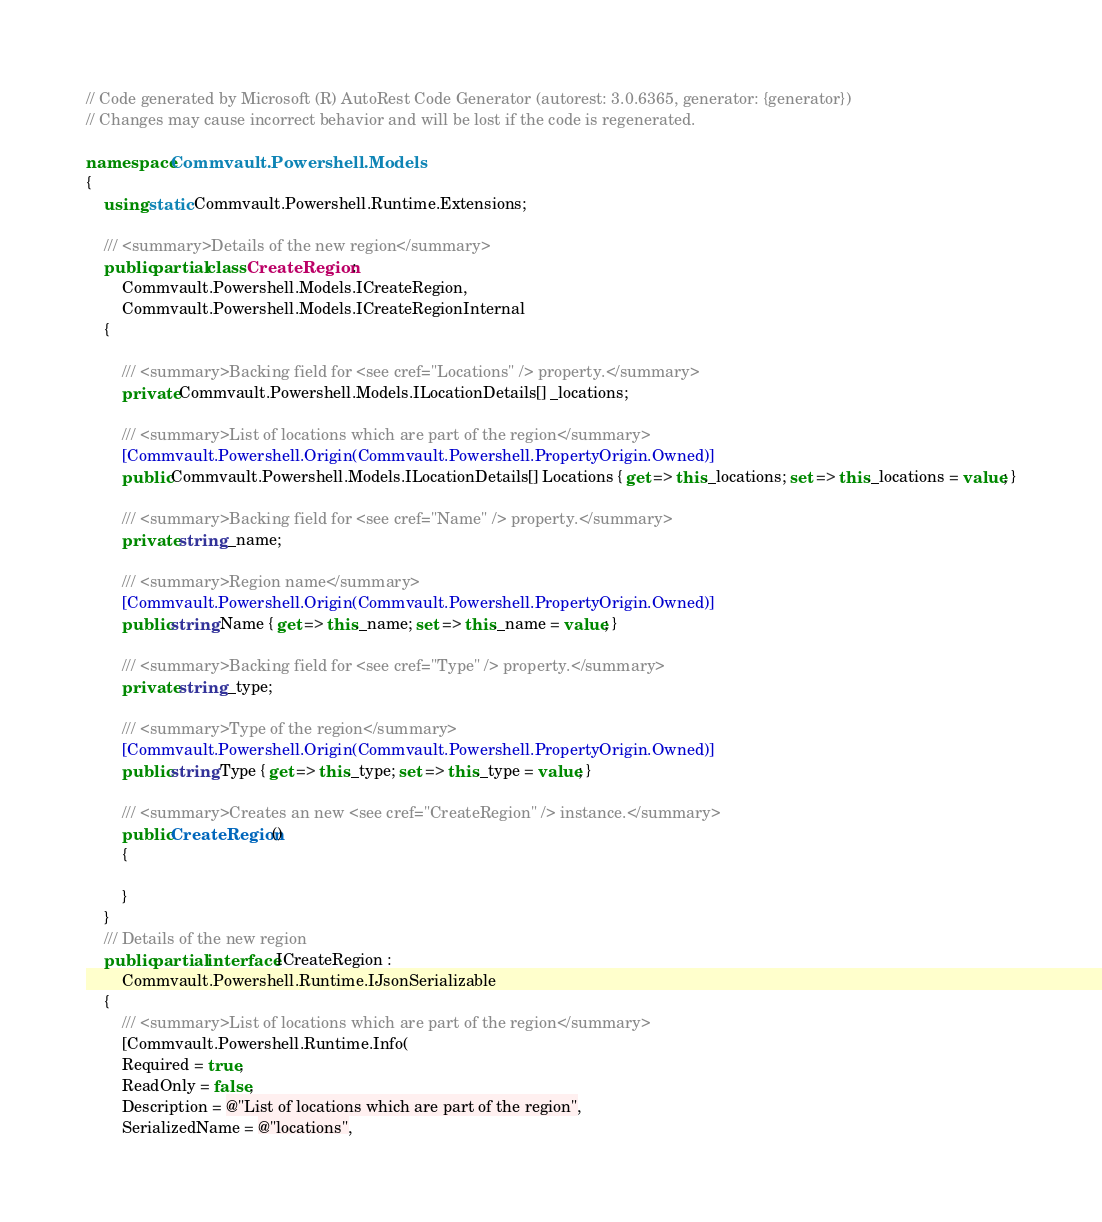<code> <loc_0><loc_0><loc_500><loc_500><_C#_>// Code generated by Microsoft (R) AutoRest Code Generator (autorest: 3.0.6365, generator: {generator})
// Changes may cause incorrect behavior and will be lost if the code is regenerated.

namespace Commvault.Powershell.Models
{
    using static Commvault.Powershell.Runtime.Extensions;

    /// <summary>Details of the new region</summary>
    public partial class CreateRegion :
        Commvault.Powershell.Models.ICreateRegion,
        Commvault.Powershell.Models.ICreateRegionInternal
    {

        /// <summary>Backing field for <see cref="Locations" /> property.</summary>
        private Commvault.Powershell.Models.ILocationDetails[] _locations;

        /// <summary>List of locations which are part of the region</summary>
        [Commvault.Powershell.Origin(Commvault.Powershell.PropertyOrigin.Owned)]
        public Commvault.Powershell.Models.ILocationDetails[] Locations { get => this._locations; set => this._locations = value; }

        /// <summary>Backing field for <see cref="Name" /> property.</summary>
        private string _name;

        /// <summary>Region name</summary>
        [Commvault.Powershell.Origin(Commvault.Powershell.PropertyOrigin.Owned)]
        public string Name { get => this._name; set => this._name = value; }

        /// <summary>Backing field for <see cref="Type" /> property.</summary>
        private string _type;

        /// <summary>Type of the region</summary>
        [Commvault.Powershell.Origin(Commvault.Powershell.PropertyOrigin.Owned)]
        public string Type { get => this._type; set => this._type = value; }

        /// <summary>Creates an new <see cref="CreateRegion" /> instance.</summary>
        public CreateRegion()
        {

        }
    }
    /// Details of the new region
    public partial interface ICreateRegion :
        Commvault.Powershell.Runtime.IJsonSerializable
    {
        /// <summary>List of locations which are part of the region</summary>
        [Commvault.Powershell.Runtime.Info(
        Required = true,
        ReadOnly = false,
        Description = @"List of locations which are part of the region",
        SerializedName = @"locations",</code> 